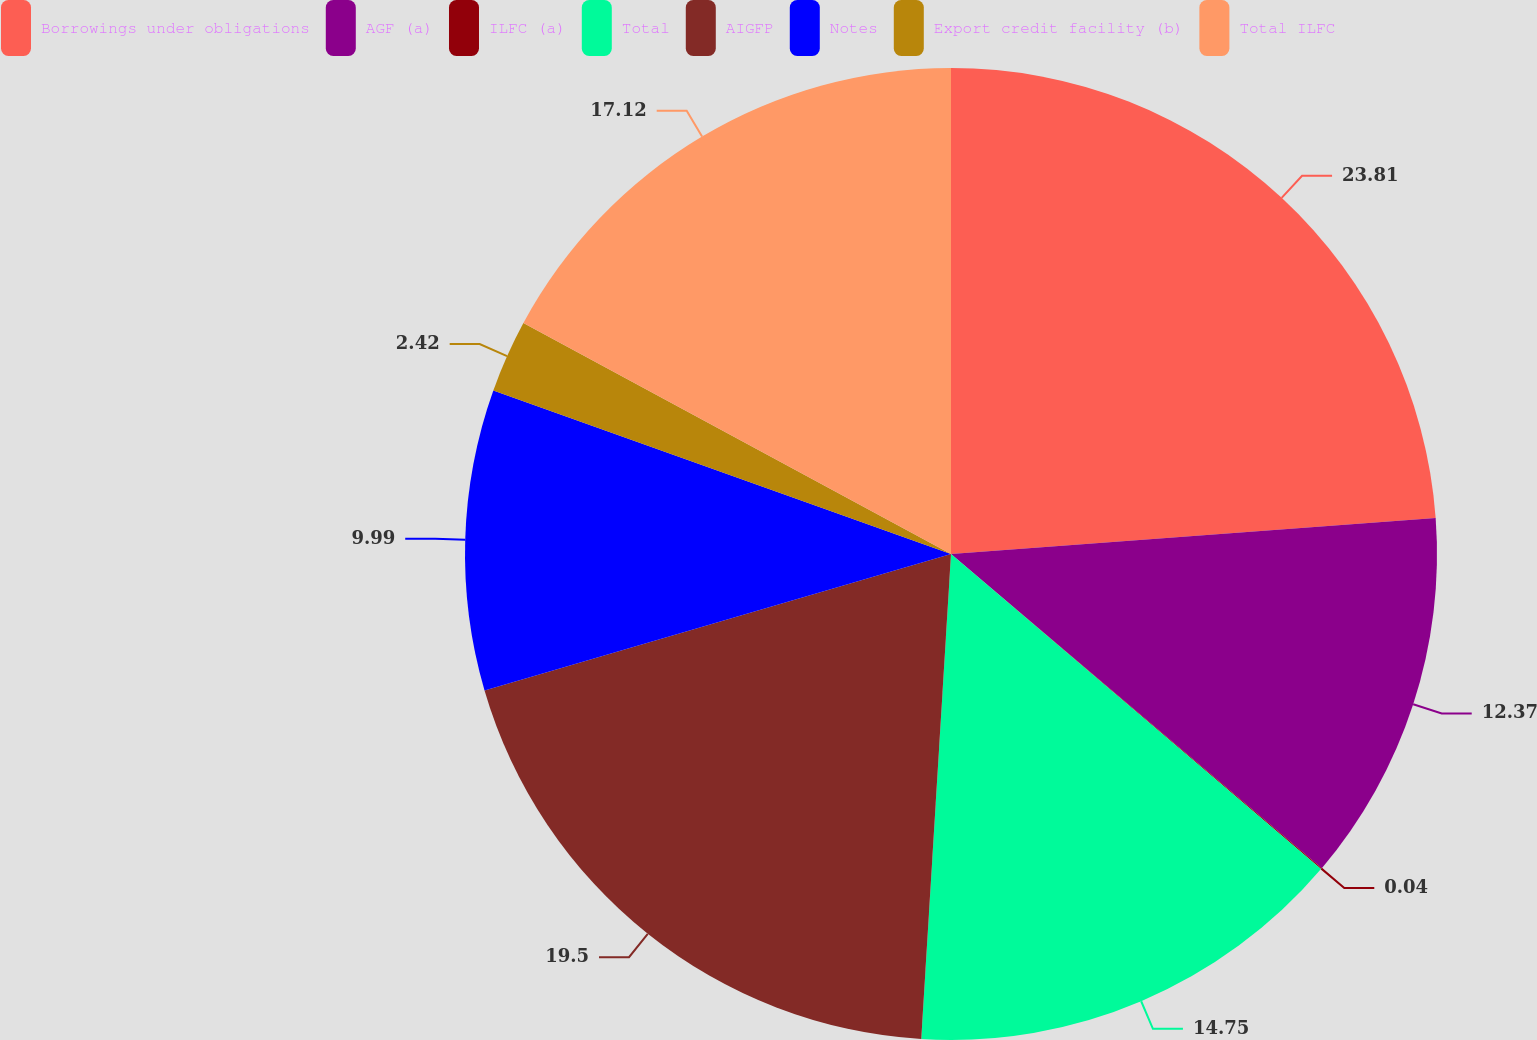<chart> <loc_0><loc_0><loc_500><loc_500><pie_chart><fcel>Borrowings under obligations<fcel>AGF (a)<fcel>ILFC (a)<fcel>Total<fcel>AIGFP<fcel>Notes<fcel>Export credit facility (b)<fcel>Total ILFC<nl><fcel>23.82%<fcel>12.37%<fcel>0.04%<fcel>14.75%<fcel>19.5%<fcel>9.99%<fcel>2.42%<fcel>17.12%<nl></chart> 